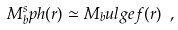Convert formula to latex. <formula><loc_0><loc_0><loc_500><loc_500>M _ { b } ^ { s } p h ( r ) \simeq M _ { b } u l g e f ( r ) \ ,</formula> 